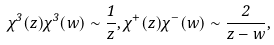<formula> <loc_0><loc_0><loc_500><loc_500>\chi ^ { 3 } ( z ) \chi ^ { 3 } ( w ) \sim \frac { 1 } { z } , \chi ^ { + } ( z ) \chi ^ { - } ( w ) \sim \frac { 2 } { z - w } ,</formula> 